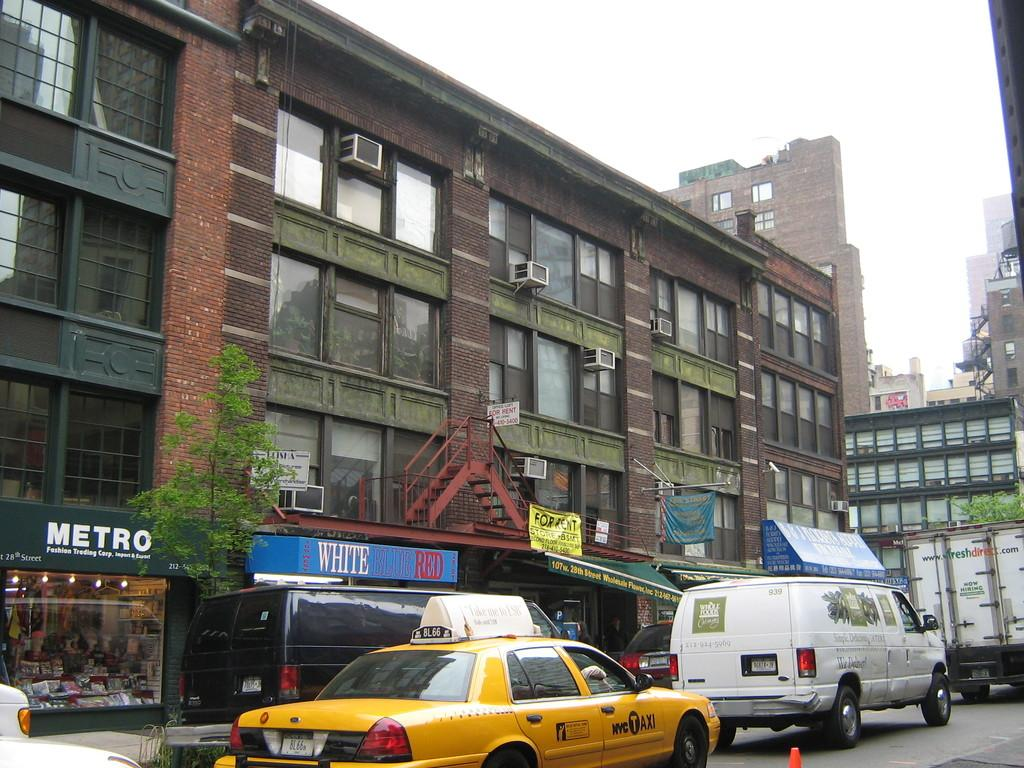<image>
Present a compact description of the photo's key features. a Metro building near the road and a taxi 